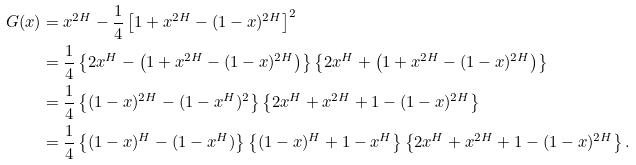Convert formula to latex. <formula><loc_0><loc_0><loc_500><loc_500>G ( x ) & = x ^ { 2 H } - \frac { 1 } { 4 } \left [ 1 + x ^ { 2 H } - ( 1 - x ) ^ { 2 H } \right ] ^ { 2 } \\ & = \frac { 1 } { 4 } \left \{ 2 x ^ { H } - \left ( 1 + x ^ { 2 H } - ( 1 - x ) ^ { 2 H } \right ) \right \} \left \{ 2 x ^ { H } + \left ( 1 + x ^ { 2 H } - ( 1 - x ) ^ { 2 H } \right ) \right \} \\ & = \frac { 1 } { 4 } \left \{ ( 1 - x ) ^ { 2 H } - ( 1 - x ^ { H } ) ^ { 2 } \right \} \left \{ 2 x ^ { H } + x ^ { 2 H } + 1 - ( 1 - x ) ^ { 2 H } \right \} \\ & = \frac { 1 } { 4 } \left \{ ( 1 - x ) ^ { H } - ( 1 - x ^ { H } ) \right \} \left \{ ( 1 - x ) ^ { H } + 1 - x ^ { H } \right \} \left \{ 2 x ^ { H } + x ^ { 2 H } + 1 - ( 1 - x ) ^ { 2 H } \right \} .</formula> 